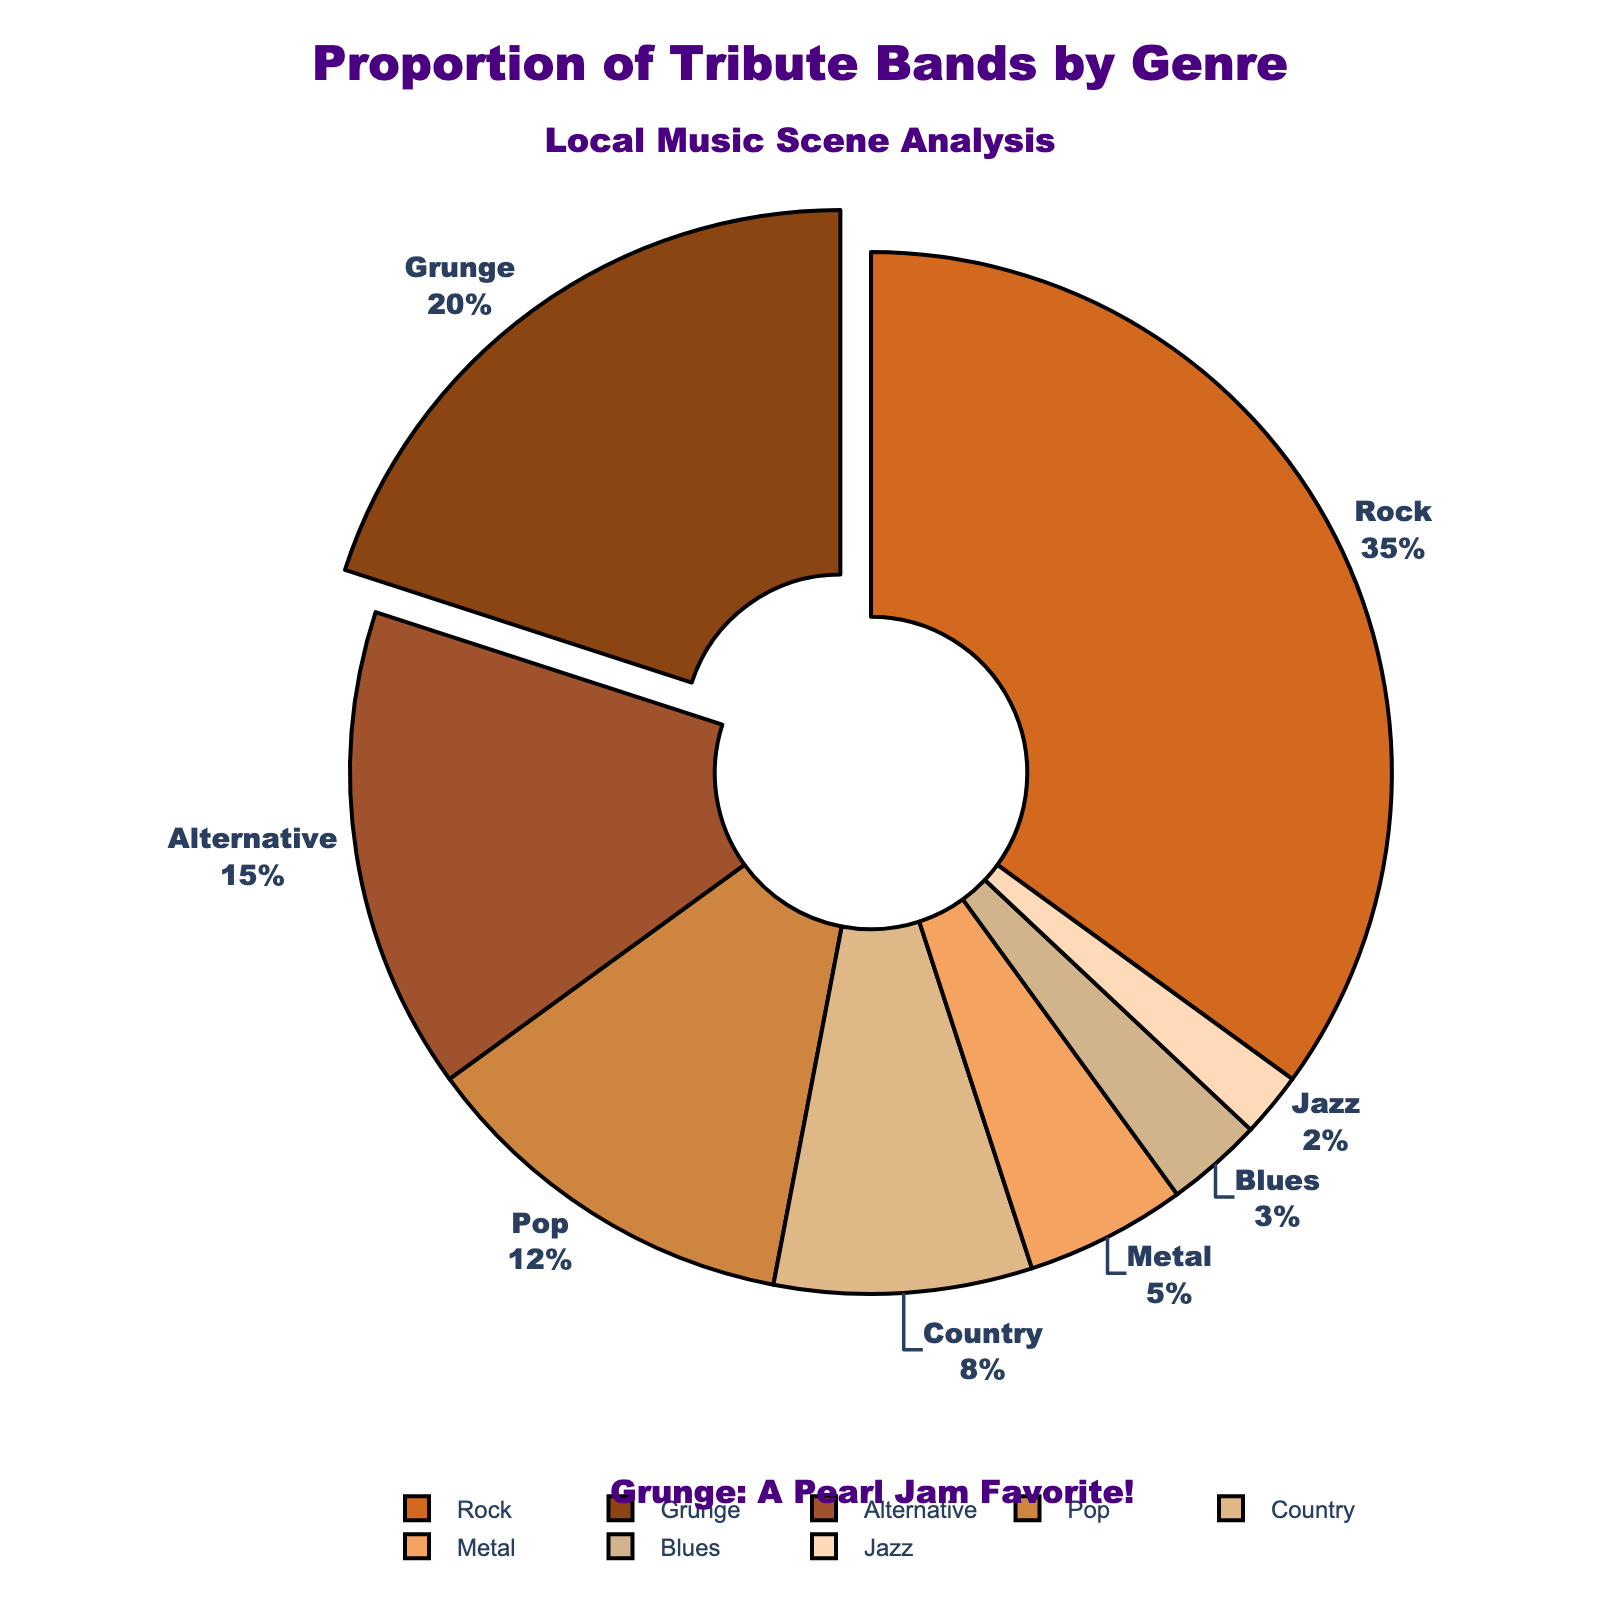What genre has the largest proportion of tribute bands? The figure shows that the Rock genre occupies the largest section of the pie chart, labeled with 35%.
Answer: Rock Which genre is highlighted in the chart, and why do you think that is? The Grunge genre is pulled out slightly from the pie chart and also includes an annotation about Pearl Jam, suggesting that Pearl Jam (a famous Grunge band) is a favorite.
Answer: Grunge What is the combined percentage of tribute bands for Pop and Country genres? Pop tribute bands represent 12%, and Country tribute bands represent 8%. Adding these two percentages together gives us 12 + 8 = 20%.
Answer: 20% How much larger is the percentage of Rock tribute bands compared to Metal tribute bands? Rock tribute bands represent 35%, and Metal tribute bands represent 5%. To find the difference, subtract the smaller percentage from the larger one: 35 - 5 = 30%.
Answer: 30% What is the second most popular genre for tribute bands? Referring to the chart, the Grunge genre is the second most popular with 20% of the tribute bands.
Answer: Grunge Which genres have less than 10% representation of tribute bands? By looking at the chart, Country (8%), Metal (5%), Blues (3%), and Jazz (2%) all have less than 10% representation.
Answer: Country, Metal, Blues, Jazz Between Blues and Jazz, which genre has a higher proportion of tribute bands? The pie chart indicates that Blues has 3% and Jazz has 2%. Therefore, Blues has a higher proportion.
Answer: Blues What percentage of tribute bands are in genres classified as Rock, Grunge, and Alternative combined? Rock is 35%, Grunge is 20%, and Alternative is 15%. Adding these percentages gives 35 + 20 + 15 = 70%.
Answer: 70% What visual elements in the chart highlight the importance of Grunge music, particularly Pearl Jam? The Grunge segment is slightly pulled out, and there's an annotation under the pie chart stating "Grunge: A Pearl Jam Favorite!"
Answer: Segment pull-out and annotation If you combined the percentages of the three smallest genres, what would their total be? Blues is 3%, Jazz is 2%, and Metal is 5%. Adding these together gives 3 + 2 + 5 = 10%.
Answer: 10% 